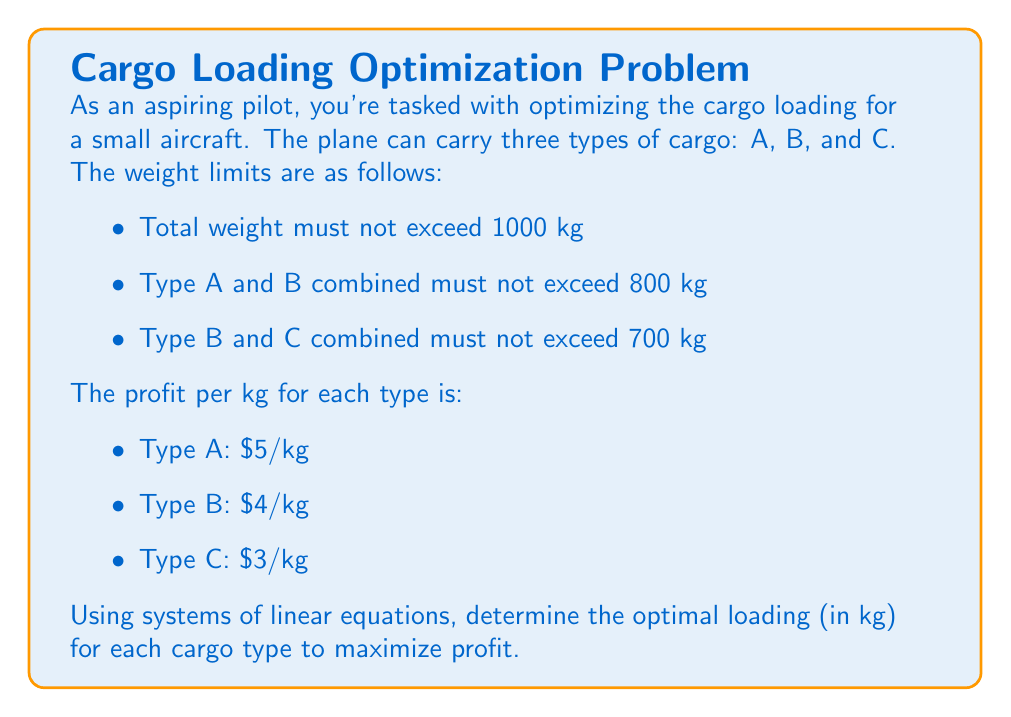Teach me how to tackle this problem. Let's approach this step-by-step using linear programming:

1) Define variables:
   Let $x$, $y$, and $z$ represent the weights of cargo types A, B, and C respectively.

2) Set up the objective function to maximize profit:
   $P = 5x + 4y + 3z$

3) Set up the constraints:
   $x + y + z \leq 1000$ (total weight)
   $x + y \leq 800$ (A and B combined)
   $y + z \leq 700$ (B and C combined)
   $x, y, z \geq 0$ (non-negative weights)

4) To solve this, we can use the simplex method or graphical method. Let's use the graphical method here.

5) From the constraints, we can deduce:
   $z \leq 1000 - x - y$
   $z \leq 700 - y$
   $x \leq 800 - y$

6) The optimal solution will be at one of the intersection points of these constraints. The candidates are:
   (800, 0, 200), (300, 500, 200), (0, 700, 0), (0, 500, 500)

7) Calculate the profit for each point:
   (800, 0, 200): $P = 5(800) + 4(0) + 3(200) = 4600$
   (300, 500, 200): $P = 5(300) + 4(500) + 3(200) = 3900$
   (0, 700, 0): $P = 5(0) + 4(700) + 3(0) = 2800$
   (0, 500, 500): $P = 5(0) + 4(500) + 3(500) = 3500$

8) The maximum profit is achieved at the point (800, 0, 200).
Answer: The optimal loading is:
Type A: 800 kg
Type B: 0 kg
Type C: 200 kg
Maximum profit: $4600 